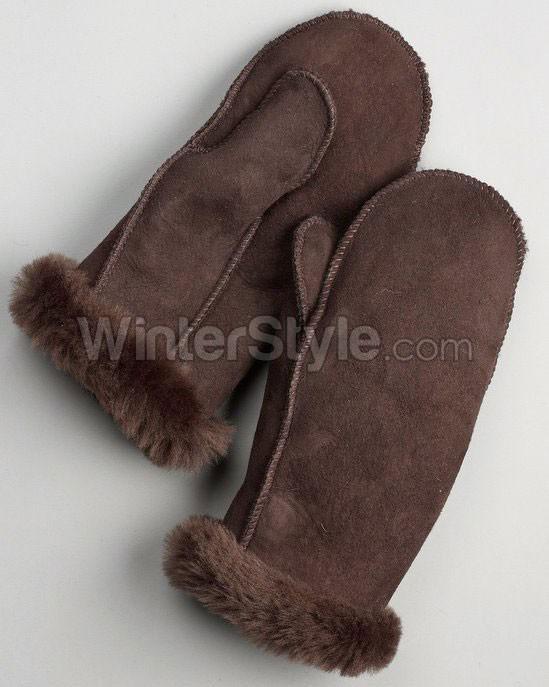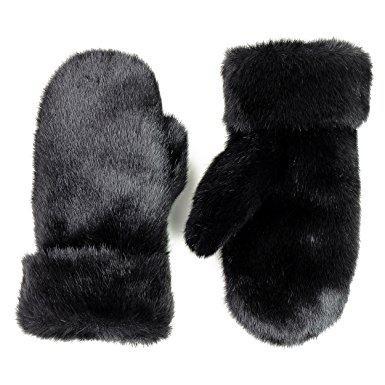The first image is the image on the left, the second image is the image on the right. Examine the images to the left and right. Is the description "The left image contains one pair of mittens displayed with the cuff end up, and the right image features a pair of half-finger gloves with a mitten flap." accurate? Answer yes or no. No. The first image is the image on the left, the second image is the image on the right. Analyze the images presented: Is the assertion "One of the pairs of mittens is the open-fingered style." valid? Answer yes or no. No. The first image is the image on the left, the second image is the image on the right. Evaluate the accuracy of this statement regarding the images: "The right image contains two finger less gloves.". Is it true? Answer yes or no. No. The first image is the image on the left, the second image is the image on the right. Evaluate the accuracy of this statement regarding the images: "Some of the mittens or gloves are furry and none of them are being worn.". Is it true? Answer yes or no. Yes. 